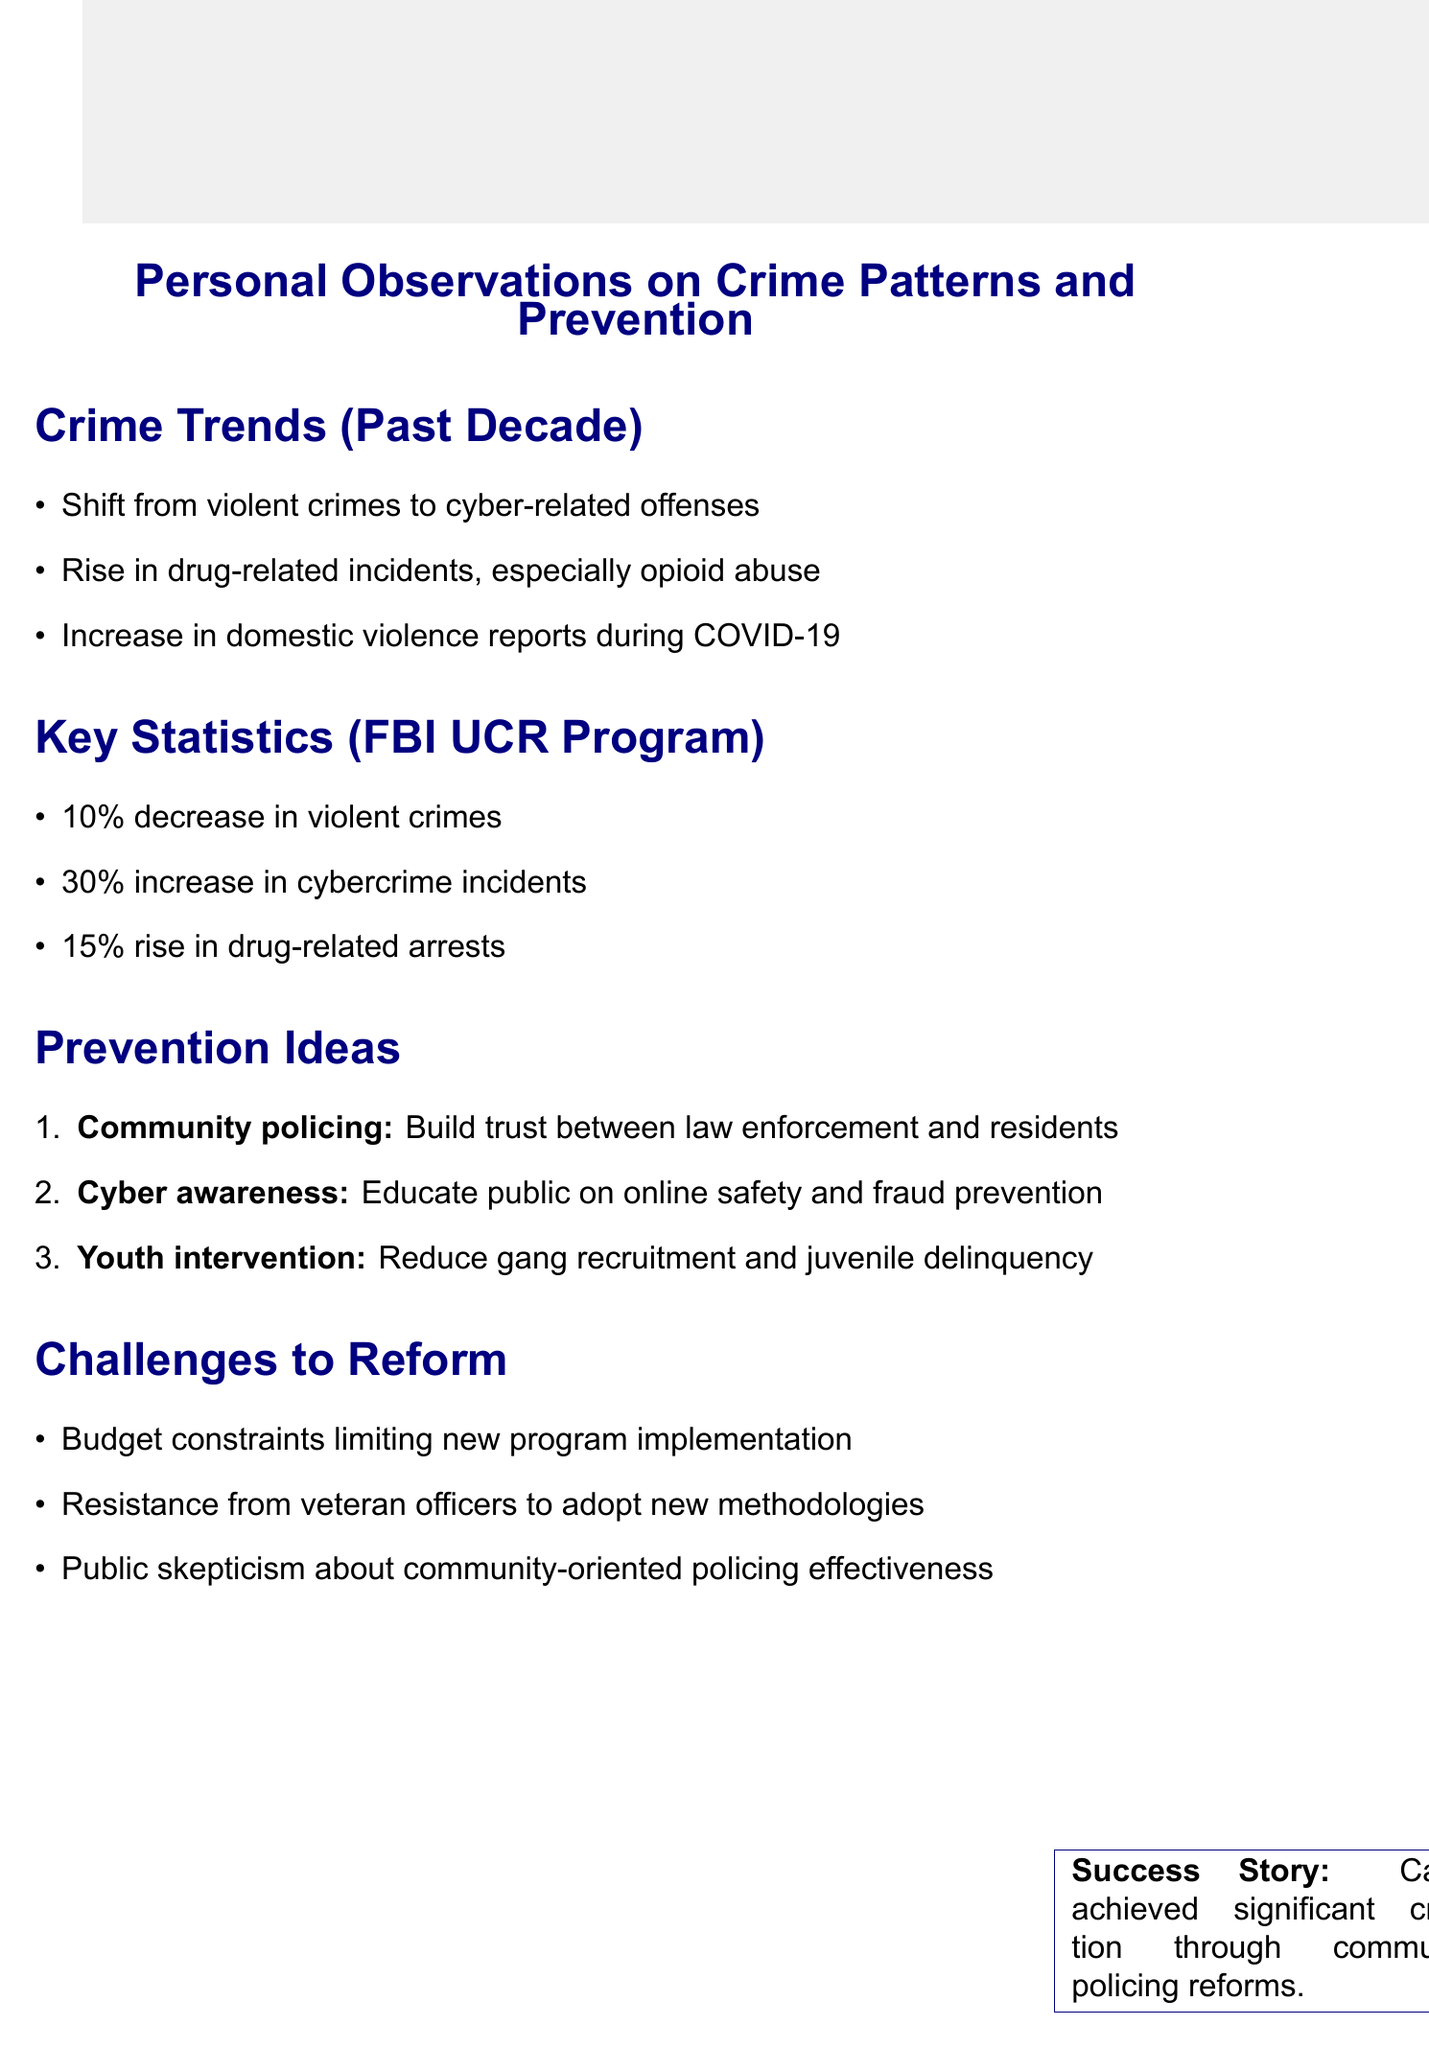What trend has shifted over the past decade? The document mentions a notable shift from violent crimes to cyber-related offenses as a crime trend.
Answer: cyber-related offenses What percentage increase is reported in cybercrime incidents? According to the key findings in the FBI UCR statistics, cybercrime incidents have increased by 30%.
Answer: 30% What is one example of drug-related incidents rising? The document states that there has been a surge in opioid abuse, especially in suburban areas, as one example of drug-related incidents.
Answer: opioid abuse What is the goal of community policing programs? The initiative aims to build trust between law enforcement and residents, as detailed in the prevention ideas section.
Answer: Build trust What is one challenge to reform mentioned in the document? Resistance from veteran officers to adopt new methodologies is listed as one challenge to reform in the document.
Answer: Resistance from veteran officers What success story is highlighted in the document? The success story of Camden, New Jersey, which achieved significant crime reduction through community-oriented policing reforms, is highlighted.
Answer: Camden, New Jersey What trend corresponds with COVID-19 lockdowns? The increase in domestic violence reports during the lockdowns is noted as a corresponding trend.
Answer: Domestic violence What type of campaigns are suggested for cyber awareness? The document suggests implementing cyber awareness campaigns to educate the public on online safety.
Answer: Cyber awareness campaigns 